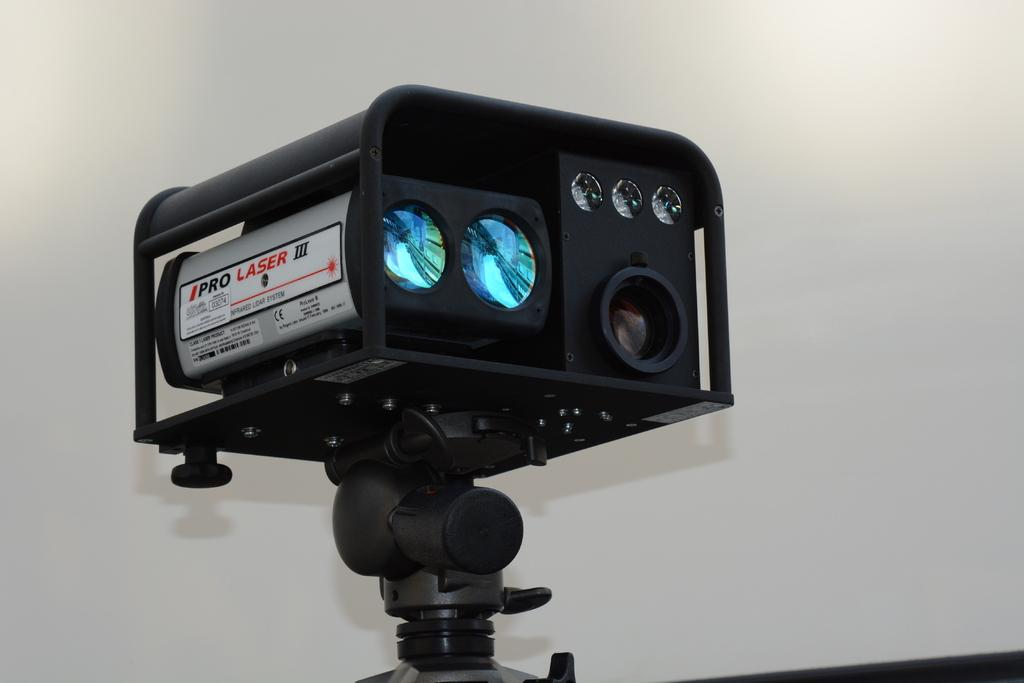What type of device is visible in the image? There is a camcorder in the image. What color is the camcorder? The camcorder is black in color. What can be seen in the background of the image? There is a wall in the background of the image. What color is the wall? The wall is white in color. What type of can is visible on the wall in the image? There is no can present in the image; it only features a camcorder and a white wall in the background. 